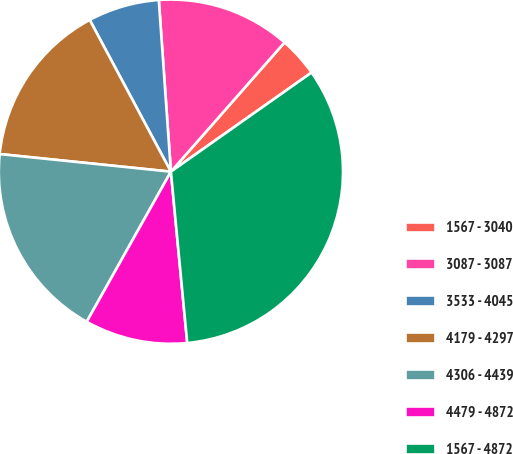<chart> <loc_0><loc_0><loc_500><loc_500><pie_chart><fcel>1567 - 3040<fcel>3087 - 3087<fcel>3533 - 4045<fcel>4179 - 4297<fcel>4306 - 4439<fcel>4479 - 4872<fcel>1567 - 4872<nl><fcel>3.75%<fcel>12.6%<fcel>6.7%<fcel>15.55%<fcel>18.5%<fcel>9.65%<fcel>33.26%<nl></chart> 